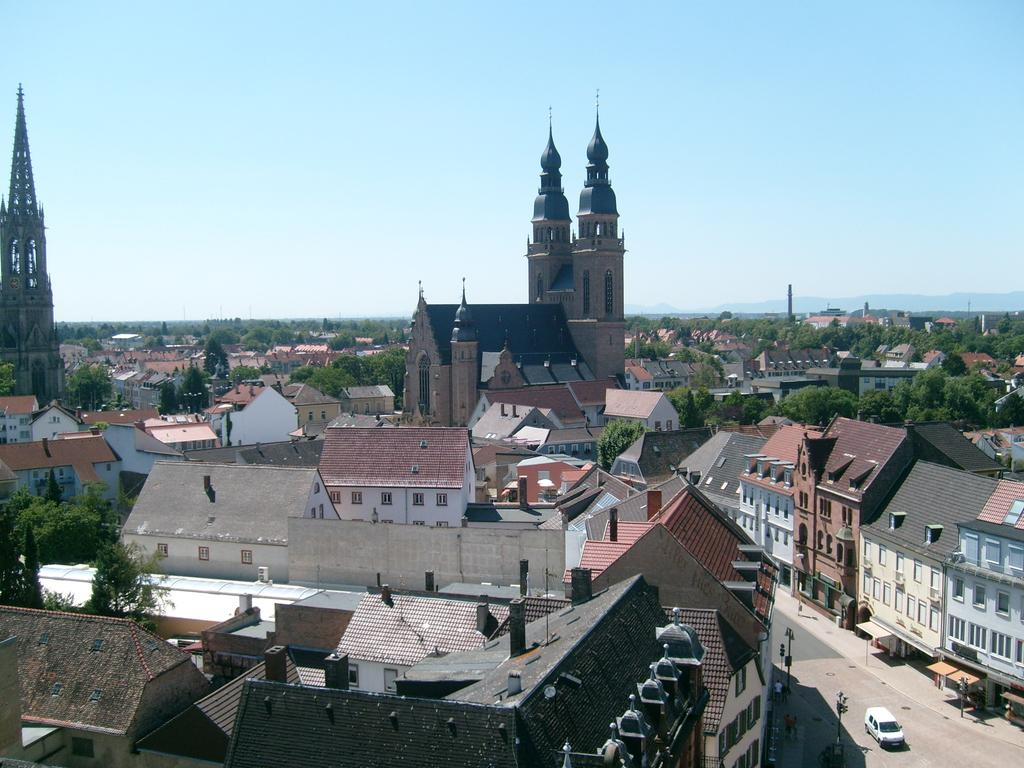What type of structures can be seen in the image? There are buildings in the image. What colors are the buildings? The buildings are in white, cream, and brown colors. What else can be seen in the image besides the buildings? There are vehicles, light poles, trees, and the sky in the image. What color are the trees? The trees are green. What is the color of the sky in the image? The sky is blue and white in color. Can you tell me how many times the credit card is used in the image? There is no credit card present in the image, so it cannot be determined how many times it is used. 